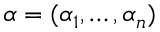<formula> <loc_0><loc_0><loc_500><loc_500>\alpha = ( \alpha _ { 1 } , \dots , \alpha _ { n } )</formula> 